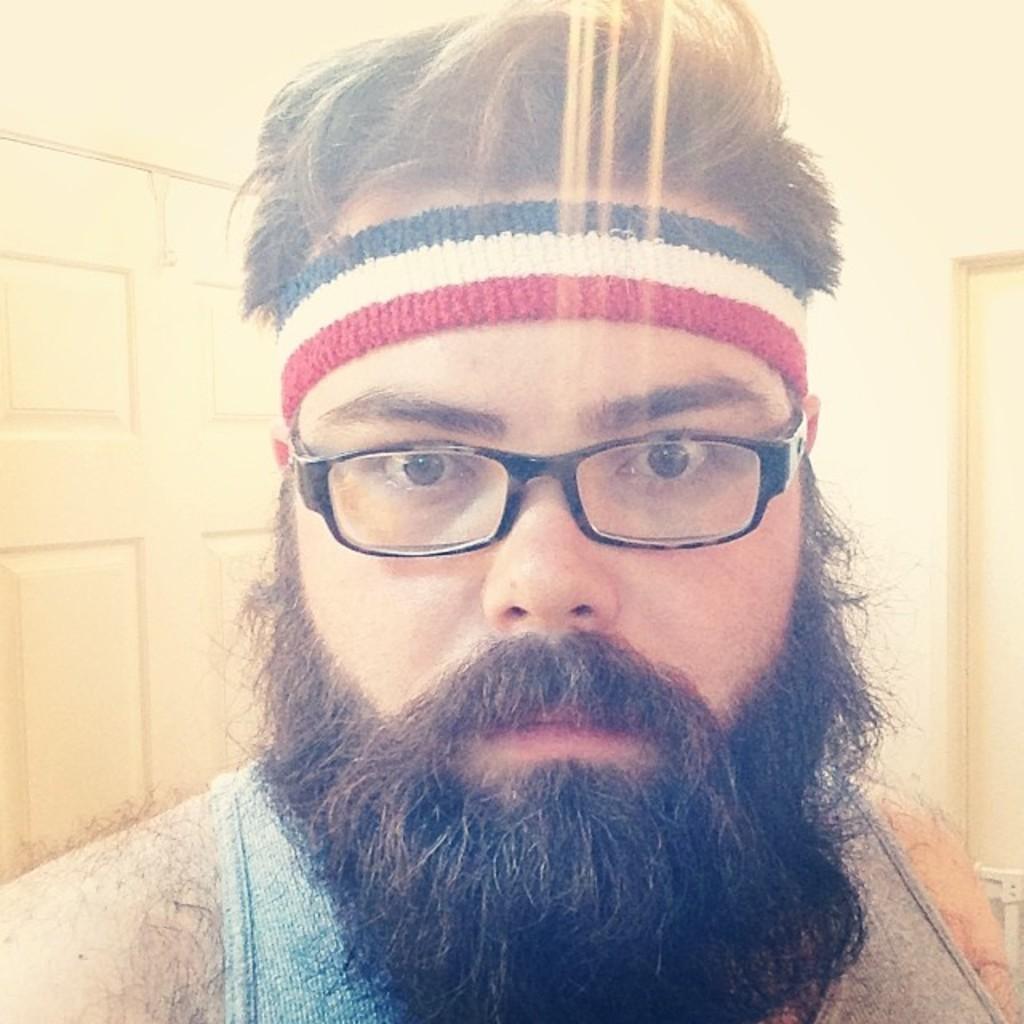Can you describe this image briefly? In this picture in the front there is a man wearing a spects and in the background there is a door. 